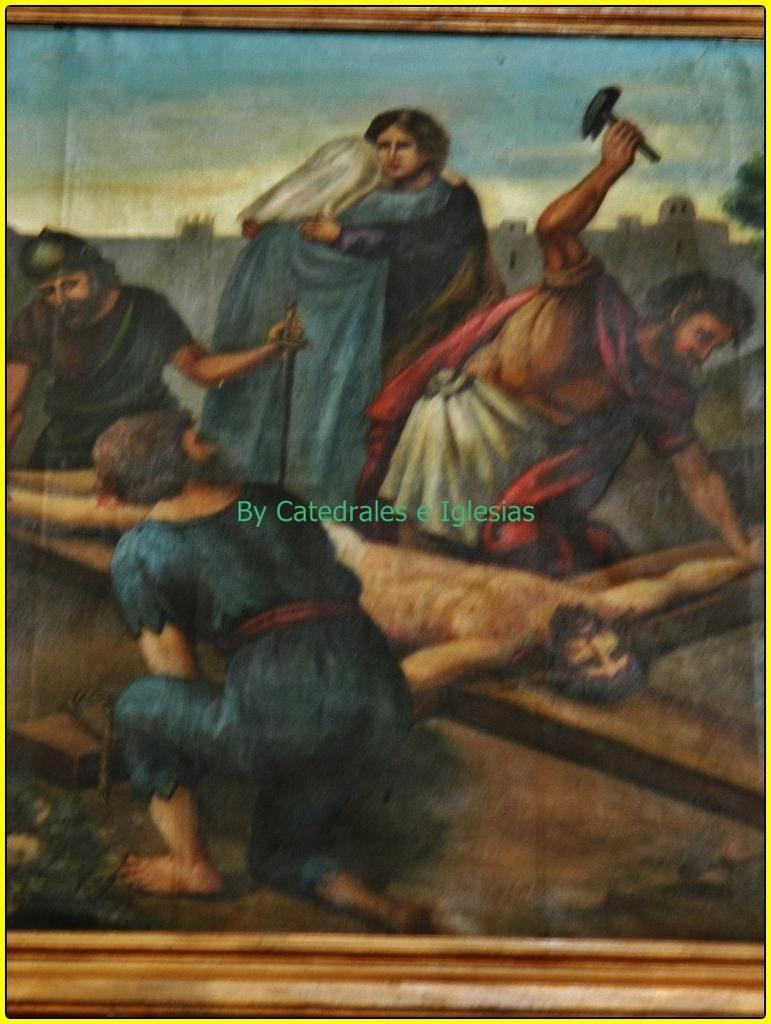Please provide a concise description of this image. In this image, we can see painting with frame. In the middle of the image, there is a watermark. 